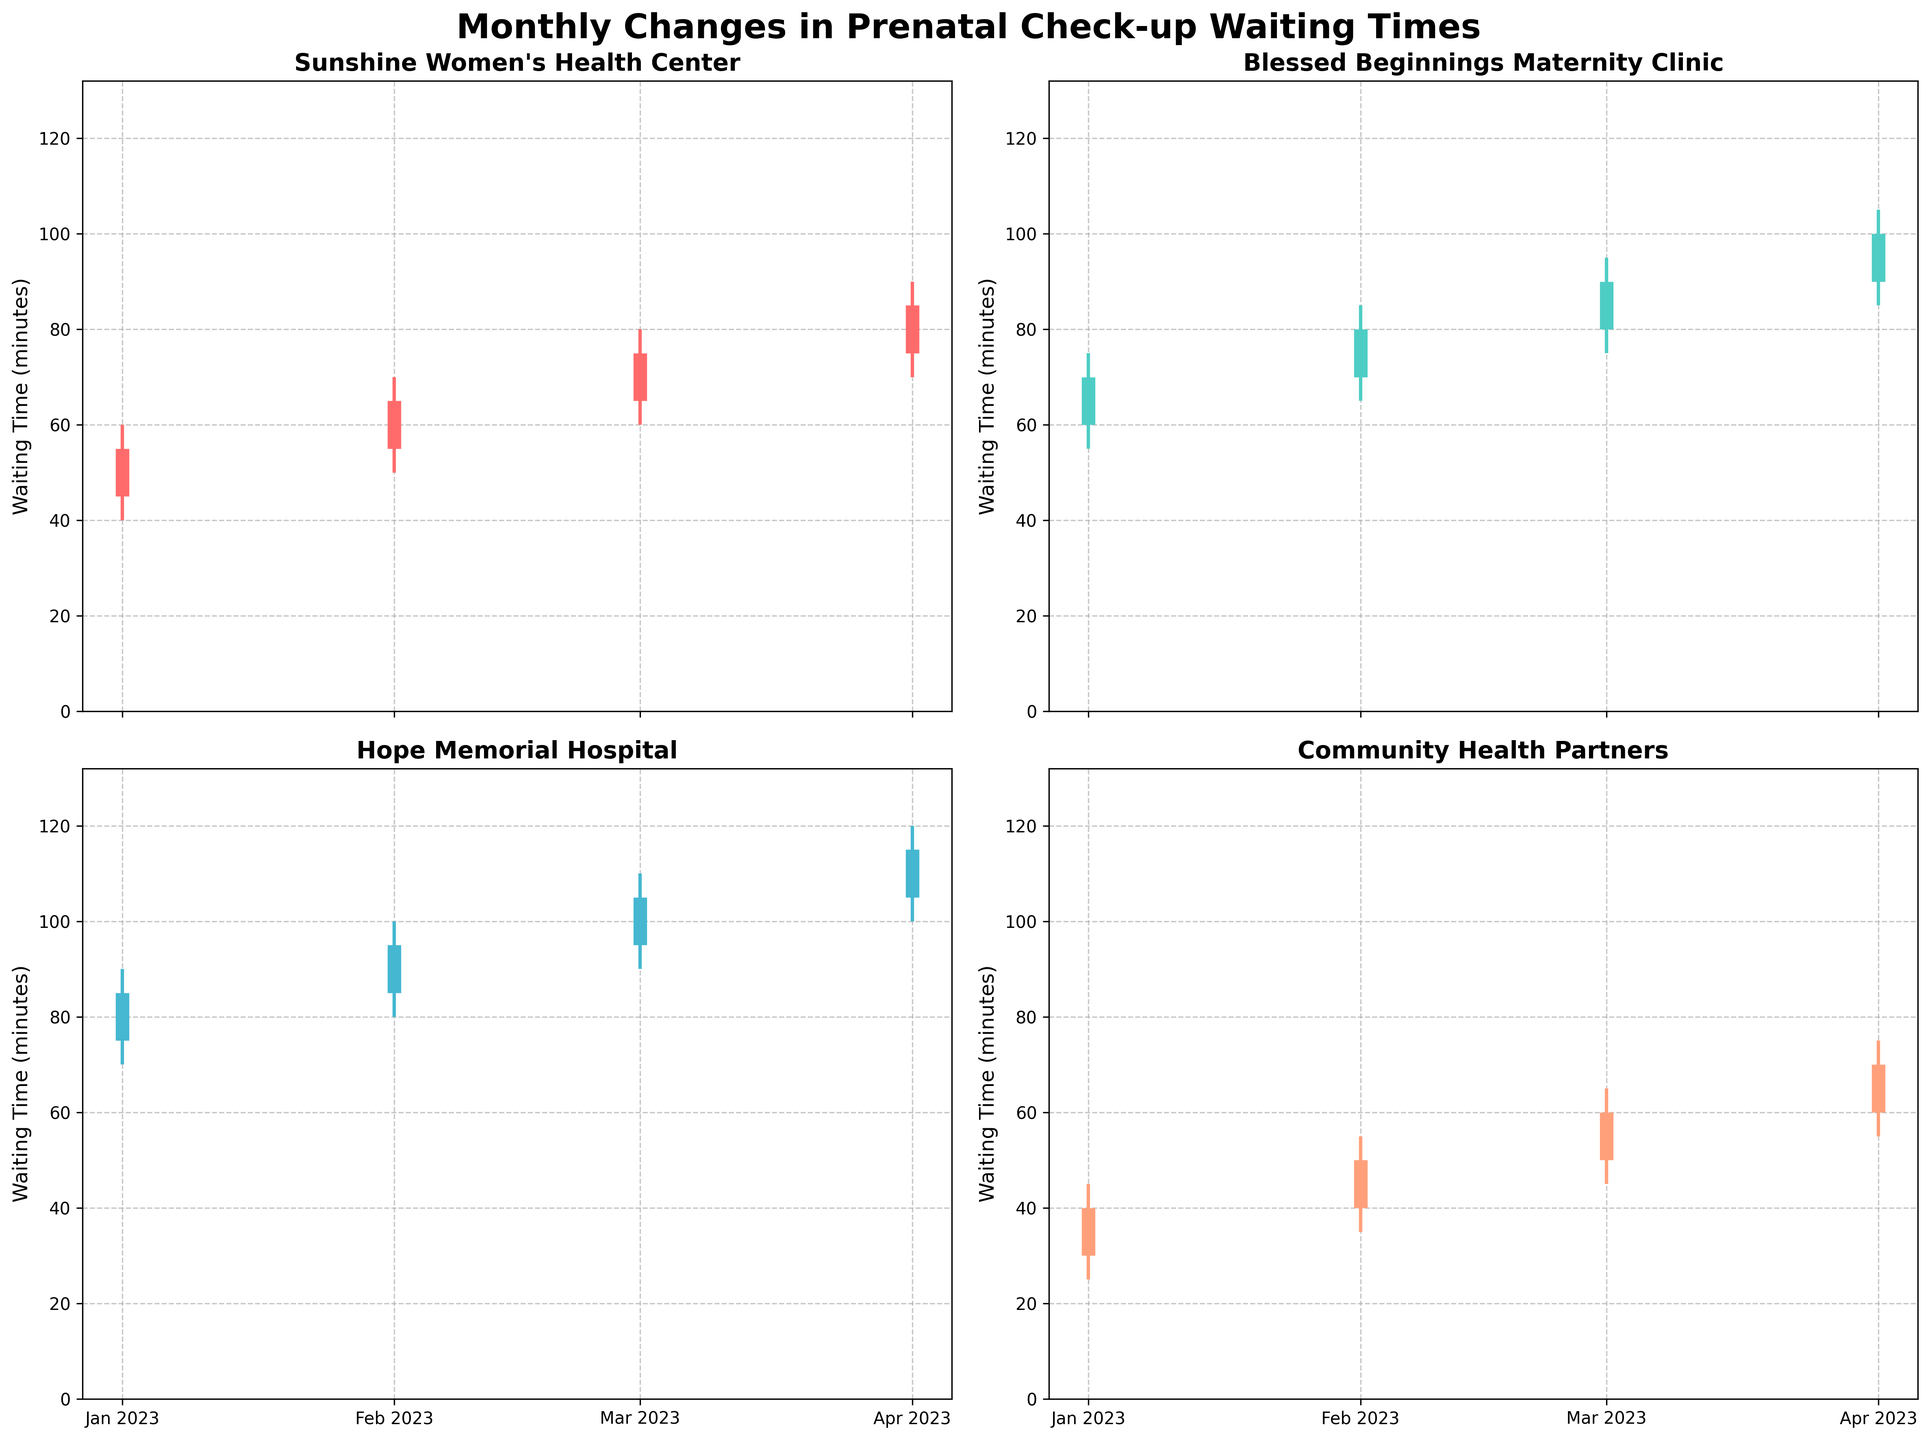How many clinics are shown in the figure? There are a total of four clinics shown in the figure: "Sunshine Women's Health Center," "Blessed Beginnings Maternity Clinic," "Hope Memorial Hospital," and "Community Health Partners."
Answer: Four Which month and clinic had the highest waiting time? The highest waiting time can be observed by looking for the tallest high point in the figure. In April 2023, Hope Memorial Hospital had the highest waiting time with the maximum value reaching 120 minutes.
Answer: April 2023, Hope Memorial Hospital Between Sunshine Women's Health Center and Hope Memorial Hospital, which clinic had a more significant increase in the opening waiting times from January to April? To compare, look at the opening times for January and April for both clinics:
   Sunshine Women's Health Center: January (45) to April (75), an increase of 30 minutes.
   Hope Memorial Hospital: January (75) to April (105), an increase of 30 minutes.
   Both clinics have the same increase of 30 minutes for opening waiting times.
Answer: Both had the same increase What is the difference in the closing waiting time between January and February for Blessed Beginnings Maternity Clinic? Look at the closing waiting times for January and February for Blessed Beginnings Maternity Clinic:
   January: 70 minutes, February: 80 minutes.
   The difference is 80 - 70 = 10 minutes.
Answer: 10 minutes Which clinic had the smallest range (difference between high and low) in waiting times in April? Calculate the ranges for April for all clinics:
   Sunshine Women's Health Center: 90 - 70 = 20.
   Blessed Beginnings Maternity Clinic: 105 - 85 = 20.
   Hope Memorial Hospital: 120 - 100 = 20.
   Community Health Partners: 75 - 55 = 20.
   All clinics had the same smallest range of 20 minutes.
Answer: All clinics had the smallest range What was the opening wait time for Community Health Partners in March? Locate the opening wait time for Community Health Partners in March, which is represented by the shorter vertical bar starting point:
   The opening wait time for March is 50 minutes.
Answer: 50 minutes By how much did the closing waiting time increase from January to April for each clinic? Calculate the difference in closing waiting times from January to April for each clinic:
   Sunshine Women's Health Center: April (85) - January (55) = 30 minutes.
   Blessed Beginnings Maternity Clinic: April (100) - January (70) = 30 minutes.
   Hope Memorial Hospital: April (115) - January (85) = 30 minutes.
   Community Health Partners: April (70) - January (40) = 30 minutes.
   Each clinic had an increase of 30 minutes.
Answer: Increase 30 minutes for each clinic 